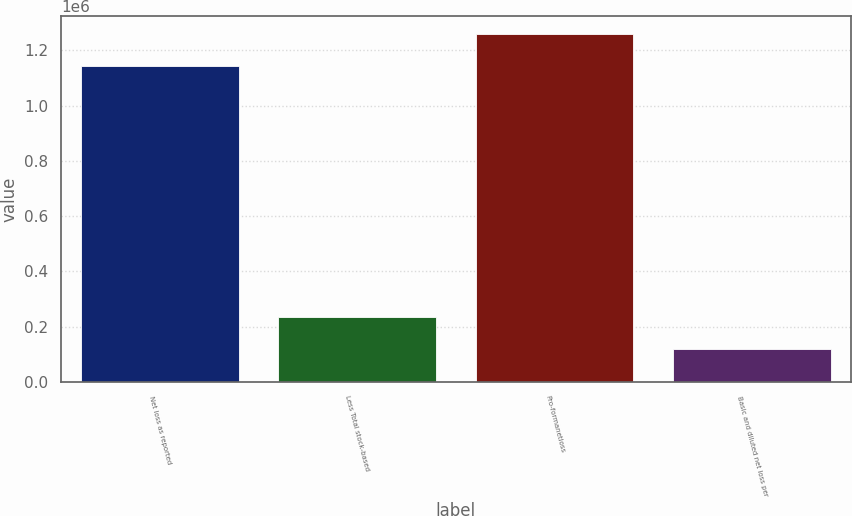<chart> <loc_0><loc_0><loc_500><loc_500><bar_chart><fcel>Net loss as reported<fcel>Less Total stock-based<fcel>Pro-formanetloss<fcel>Basic and diluted net loss per<nl><fcel>1.14188e+06<fcel>236006<fcel>1.25988e+06<fcel>118006<nl></chart> 